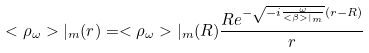Convert formula to latex. <formula><loc_0><loc_0><loc_500><loc_500>< \rho _ { \omega } > | _ { m } ( r ) = < \rho _ { \omega } > | _ { m } ( R ) \frac { R e ^ { - \sqrt { - i \frac { \omega } { < \beta > | _ { m } } } ( r - R ) } } { r }</formula> 